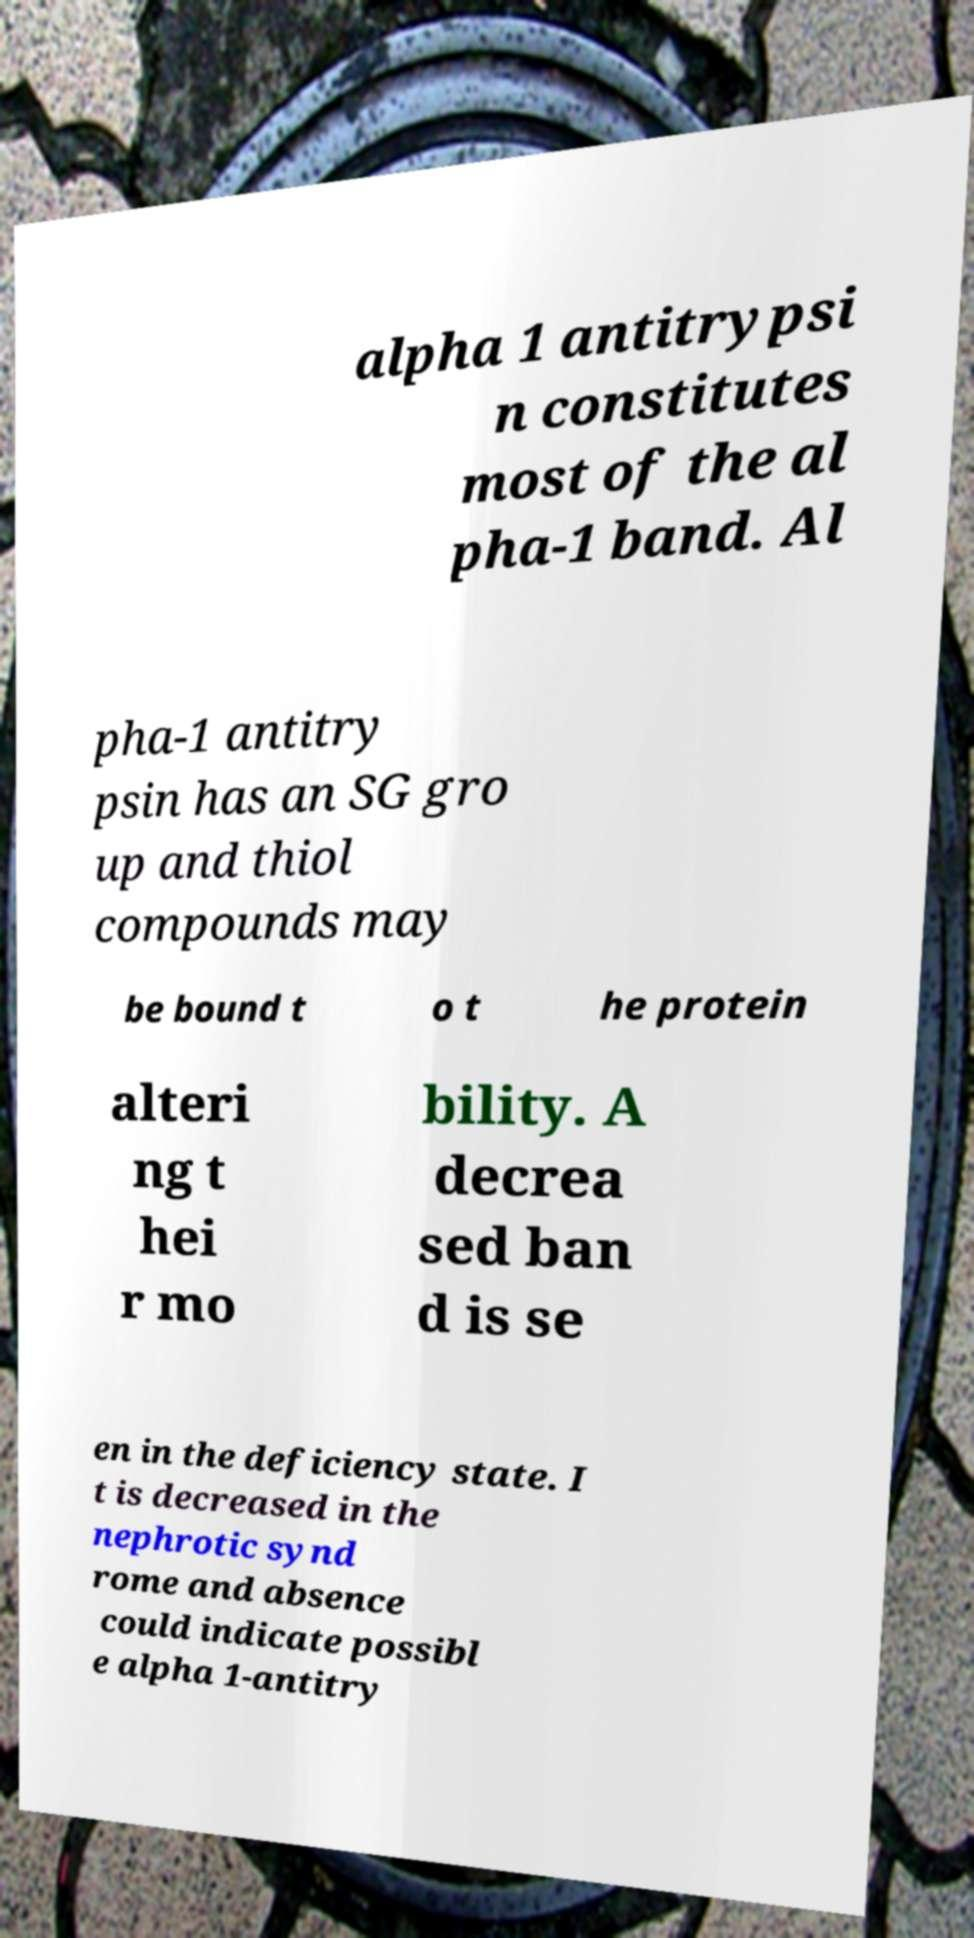What messages or text are displayed in this image? I need them in a readable, typed format. alpha 1 antitrypsi n constitutes most of the al pha-1 band. Al pha-1 antitry psin has an SG gro up and thiol compounds may be bound t o t he protein alteri ng t hei r mo bility. A decrea sed ban d is se en in the deficiency state. I t is decreased in the nephrotic synd rome and absence could indicate possibl e alpha 1-antitry 